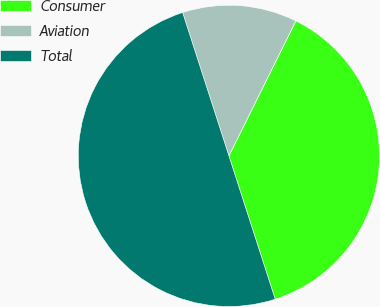<chart> <loc_0><loc_0><loc_500><loc_500><pie_chart><fcel>Consumer<fcel>Aviation<fcel>Total<nl><fcel>37.7%<fcel>12.3%<fcel>50.0%<nl></chart> 